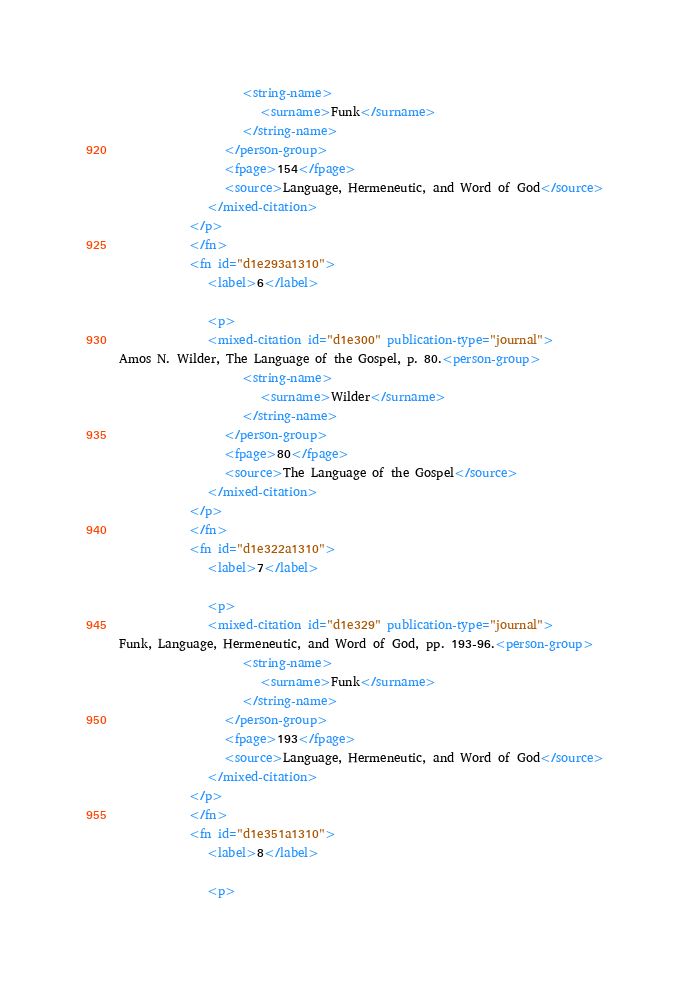<code> <loc_0><loc_0><loc_500><loc_500><_XML_>                     <string-name>
                        <surname>Funk</surname>
                     </string-name>
                  </person-group>
                  <fpage>154</fpage>
                  <source>Language, Hermeneutic, and Word of God</source>
               </mixed-citation>
            </p>
            </fn>
            <fn id="d1e293a1310">
               <label>6</label>
               
               <p>
               <mixed-citation id="d1e300" publication-type="journal">
Amos N. Wilder, The Language of the Gospel, p. 80.<person-group>
                     <string-name>
                        <surname>Wilder</surname>
                     </string-name>
                  </person-group>
                  <fpage>80</fpage>
                  <source>The Language of the Gospel</source>
               </mixed-citation>
            </p>
            </fn>
            <fn id="d1e322a1310">
               <label>7</label>
               
               <p>
               <mixed-citation id="d1e329" publication-type="journal">
Funk, Language, Hermeneutic, and Word of God, pp. 193-96.<person-group>
                     <string-name>
                        <surname>Funk</surname>
                     </string-name>
                  </person-group>
                  <fpage>193</fpage>
                  <source>Language, Hermeneutic, and Word of God</source>
               </mixed-citation>
            </p>
            </fn>
            <fn id="d1e351a1310">
               <label>8</label>
               
               <p></code> 